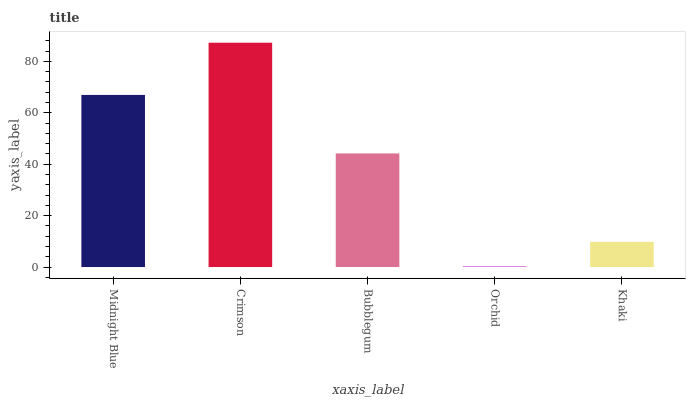Is Orchid the minimum?
Answer yes or no. Yes. Is Crimson the maximum?
Answer yes or no. Yes. Is Bubblegum the minimum?
Answer yes or no. No. Is Bubblegum the maximum?
Answer yes or no. No. Is Crimson greater than Bubblegum?
Answer yes or no. Yes. Is Bubblegum less than Crimson?
Answer yes or no. Yes. Is Bubblegum greater than Crimson?
Answer yes or no. No. Is Crimson less than Bubblegum?
Answer yes or no. No. Is Bubblegum the high median?
Answer yes or no. Yes. Is Bubblegum the low median?
Answer yes or no. Yes. Is Orchid the high median?
Answer yes or no. No. Is Khaki the low median?
Answer yes or no. No. 